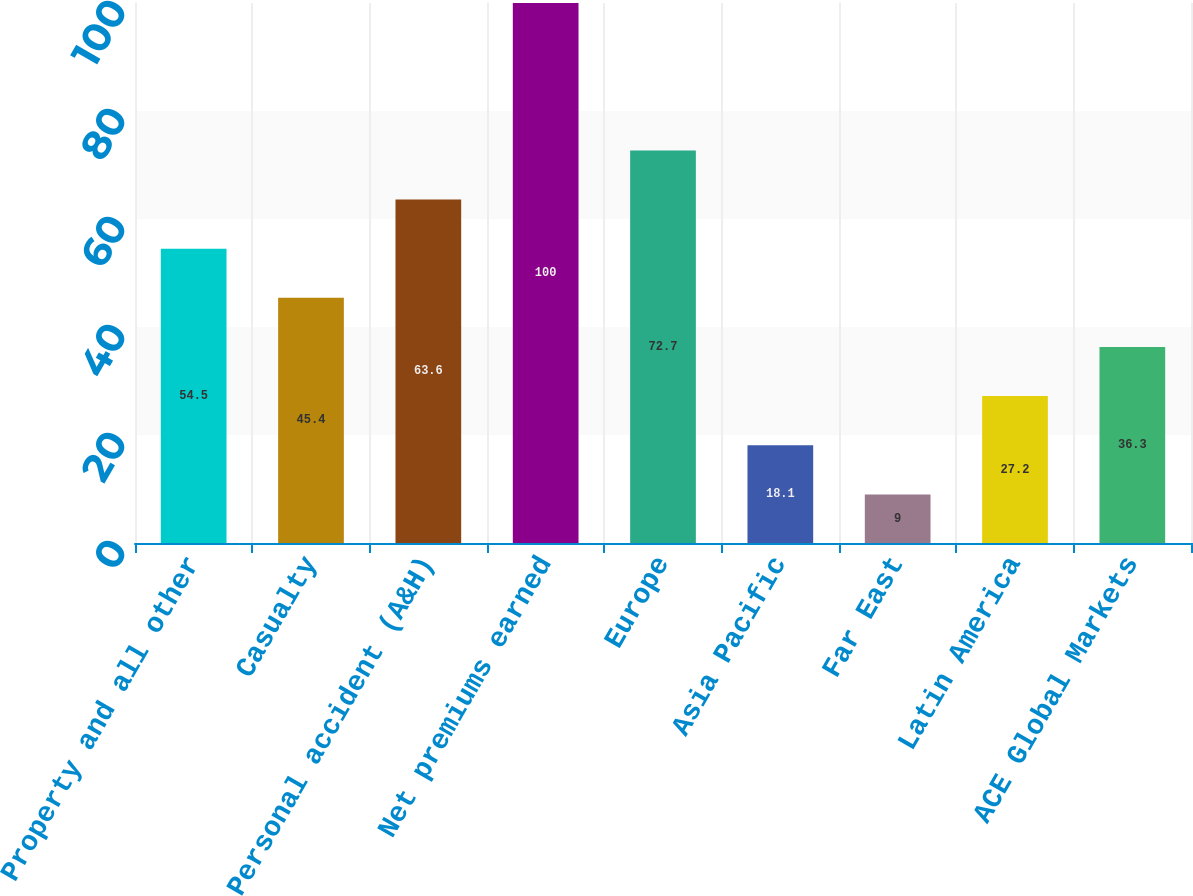<chart> <loc_0><loc_0><loc_500><loc_500><bar_chart><fcel>Property and all other<fcel>Casualty<fcel>Personal accident (A&H)<fcel>Net premiums earned<fcel>Europe<fcel>Asia Pacific<fcel>Far East<fcel>Latin America<fcel>ACE Global Markets<nl><fcel>54.5<fcel>45.4<fcel>63.6<fcel>100<fcel>72.7<fcel>18.1<fcel>9<fcel>27.2<fcel>36.3<nl></chart> 